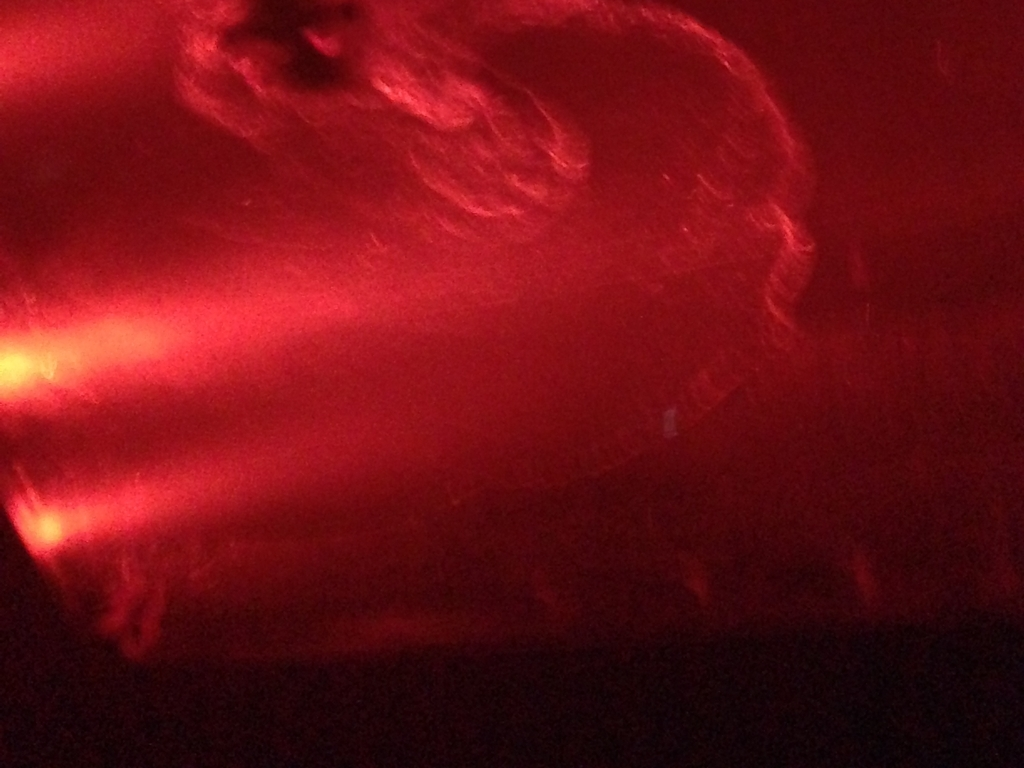Is there any artistic value or intent that can be inferred despite the low quality of the image? Despite its technical shortcomings, the image may carry artistic value, expressing motion and emotion through its blur and color dominance. This could be an intentional effect to convey a sense of dynamism or to evoke a specific mood related to the settings, like the energy and vibrancy of a live music event. 